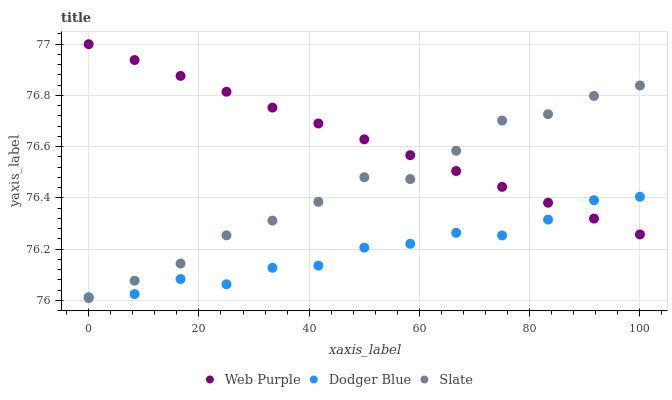Does Dodger Blue have the minimum area under the curve?
Answer yes or no. Yes. Does Web Purple have the maximum area under the curve?
Answer yes or no. Yes. Does Slate have the minimum area under the curve?
Answer yes or no. No. Does Slate have the maximum area under the curve?
Answer yes or no. No. Is Web Purple the smoothest?
Answer yes or no. Yes. Is Dodger Blue the roughest?
Answer yes or no. Yes. Is Slate the smoothest?
Answer yes or no. No. Is Slate the roughest?
Answer yes or no. No. Does Slate have the lowest value?
Answer yes or no. Yes. Does Dodger Blue have the lowest value?
Answer yes or no. No. Does Web Purple have the highest value?
Answer yes or no. Yes. Does Slate have the highest value?
Answer yes or no. No. Does Dodger Blue intersect Slate?
Answer yes or no. Yes. Is Dodger Blue less than Slate?
Answer yes or no. No. Is Dodger Blue greater than Slate?
Answer yes or no. No. 